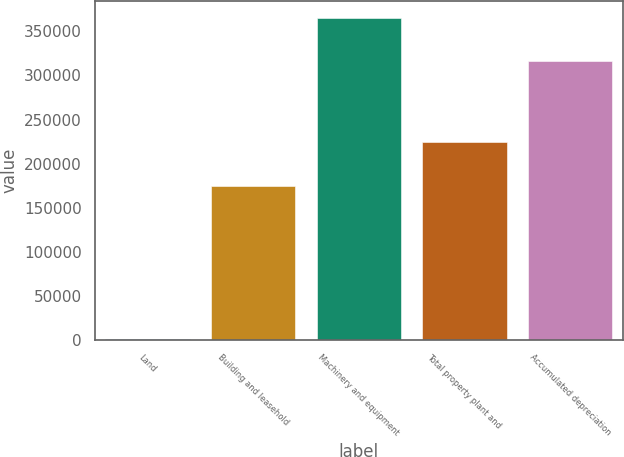Convert chart. <chart><loc_0><loc_0><loc_500><loc_500><bar_chart><fcel>Land<fcel>Building and leasehold<fcel>Machinery and equipment<fcel>Total property plant and<fcel>Accumulated depreciation<nl><fcel>906<fcel>175040<fcel>365811<fcel>224231<fcel>316620<nl></chart> 